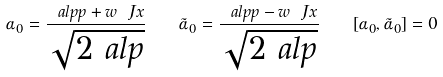<formula> <loc_0><loc_0><loc_500><loc_500>\alpha _ { 0 } = \frac { \ a l p p + w \ J x } { \sqrt { 2 \ a l p } } \quad \tilde { \alpha } _ { 0 } = \frac { \ a l p p - w \ J x } { \sqrt { 2 \ a l p } } \quad [ \alpha _ { 0 } , \tilde { \alpha } _ { 0 } ] = 0</formula> 